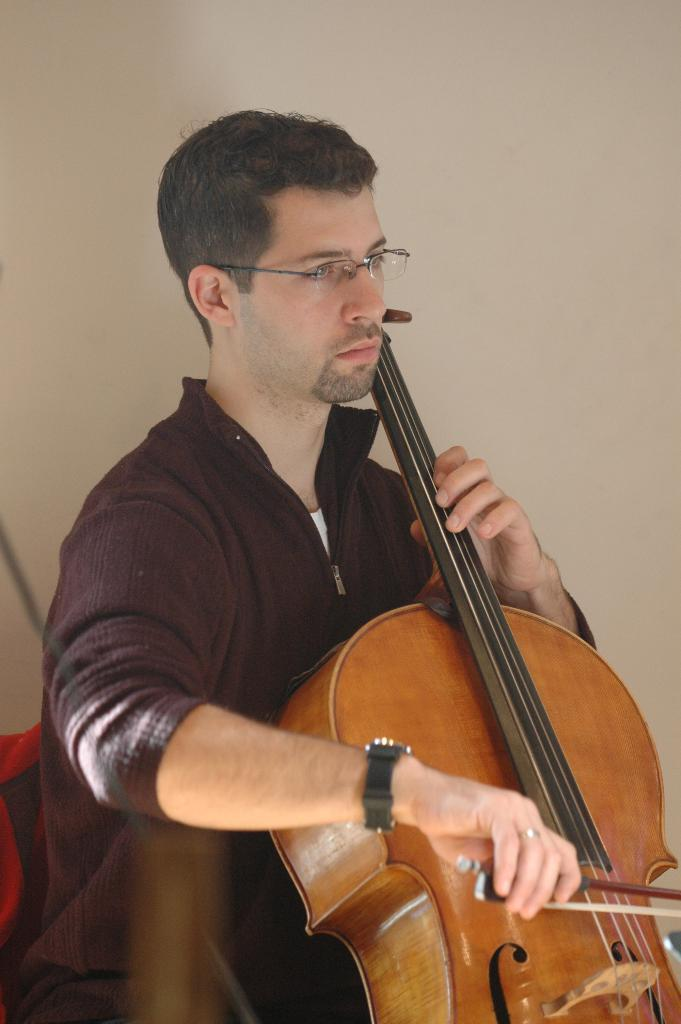Who is the main subject in the image? There is a person in the center of the image. What is the person holding in the image? The person is holding a violin. What is the person doing with the violin? The person is playing the violin. What can be seen in the background of the image? There is a wall and other objects in the background of the image. What type of star can be seen shining brightly in the image? There is no star visible in the image; it is focused on a person playing a violin. What material is the fan made of in the image? There is no fan present in the image. 